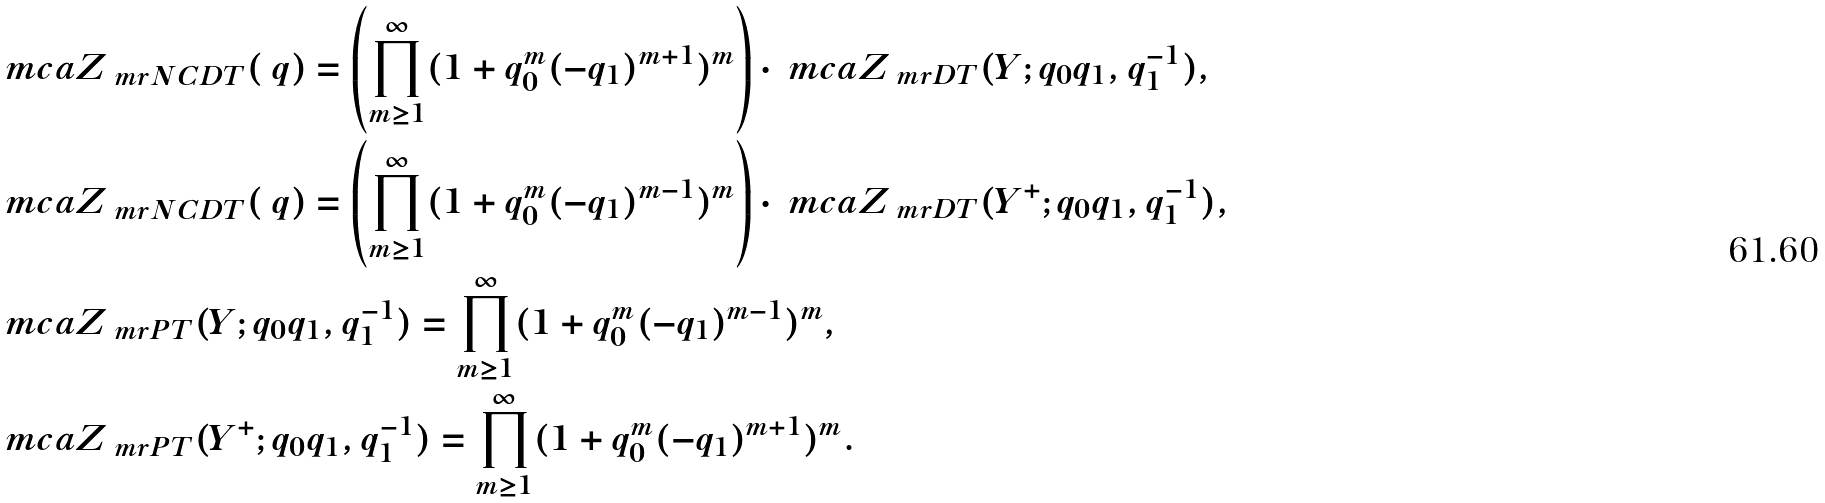<formula> <loc_0><loc_0><loc_500><loc_500>& \ m c a { Z } _ { \ m r { N C D T } } ( \ q ) = \left ( \prod _ { m \geq 1 } ^ { \infty } ( 1 + q _ { 0 } ^ { m } ( - q _ { 1 } ) ^ { m + 1 } ) ^ { m } \right ) \cdot \ m c a { Z } _ { \ m r { D T } } ( Y ; q _ { 0 } q _ { 1 } , q _ { 1 } ^ { - 1 } ) , \\ & \ m c a { Z } _ { \ m r { N C D T } } ( \ q ) = \left ( \prod _ { m \geq 1 } ^ { \infty } ( 1 + q _ { 0 } ^ { m } ( - q _ { 1 } ) ^ { m - 1 } ) ^ { m } \right ) \cdot \ m c a { Z } _ { \ m r { D T } } ( Y ^ { + } ; q _ { 0 } q _ { 1 } , q _ { 1 } ^ { - 1 } ) , \\ & \ m c a { Z } _ { \ m r { P T } } ( Y ; q _ { 0 } q _ { 1 } , q _ { 1 } ^ { - 1 } ) = \prod _ { m \geq 1 } ^ { \infty } ( 1 + q _ { 0 } ^ { m } ( - q _ { 1 } ) ^ { m - 1 } ) ^ { m } , \\ & \ m c a { Z } _ { \ m r { P T } } ( Y ^ { + } ; q _ { 0 } q _ { 1 } , q _ { 1 } ^ { - 1 } ) = \prod _ { m \geq 1 } ^ { \infty } ( 1 + q _ { 0 } ^ { m } ( - q _ { 1 } ) ^ { m + 1 } ) ^ { m } .</formula> 